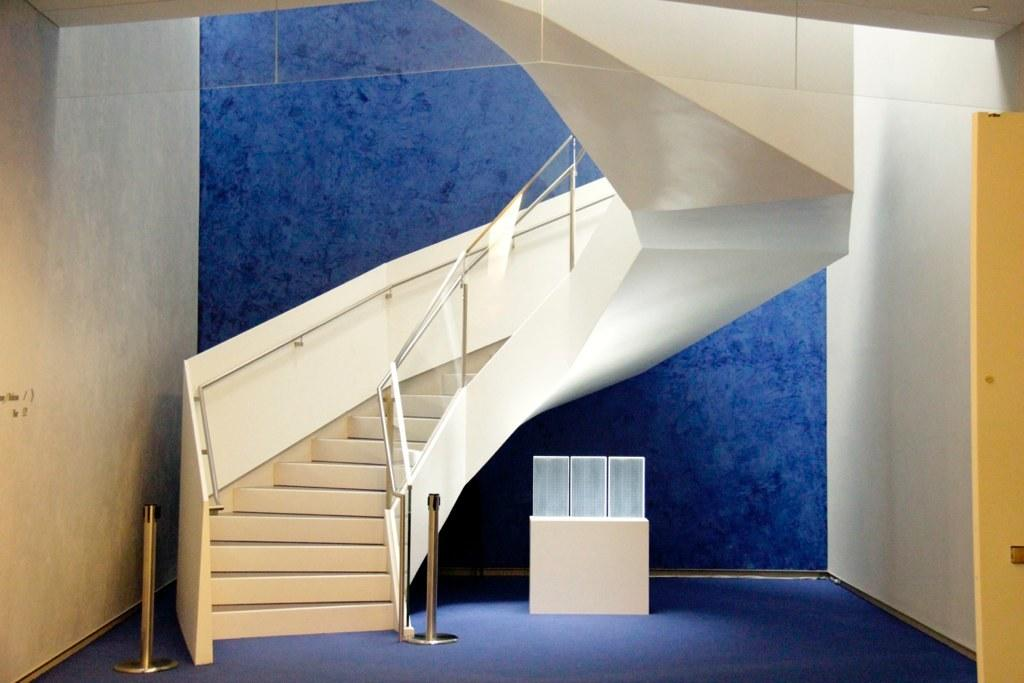What structure is located on the left side of the image? There is a staircase on the left side of the image. What can be seen on the right side of the image? There is a door on the right side of the image. What is in the center of the image? There is a desk in the center of the image. Can you see your sister on the island in the image? There is no island or sister present in the image. Is there a bridge connecting the staircase and the door in the image? There is no bridge visible in the image; it only features a staircase, a door, and a desk. 